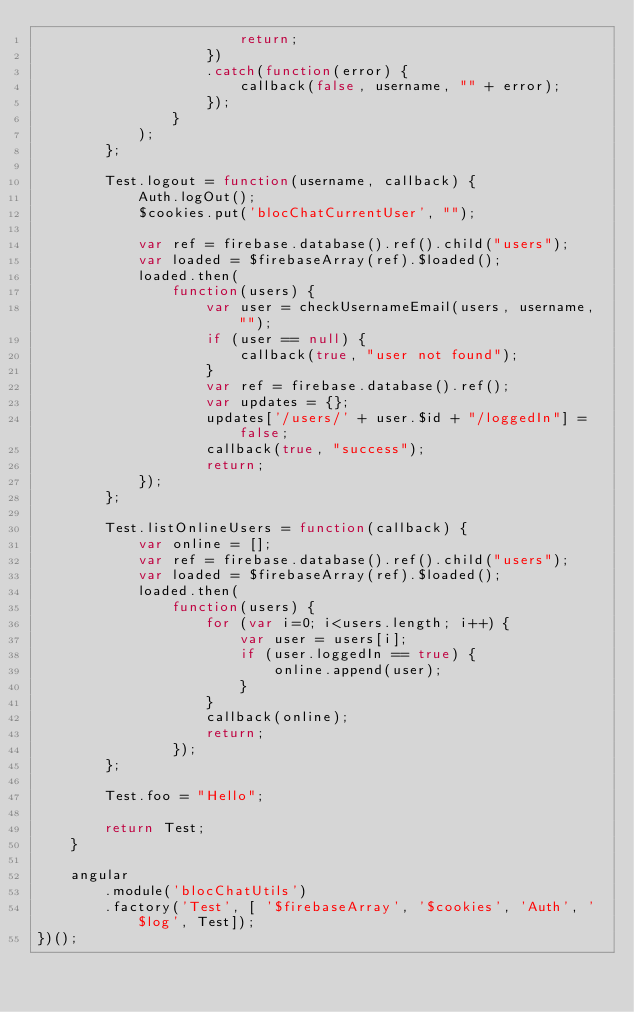<code> <loc_0><loc_0><loc_500><loc_500><_JavaScript_>                        return;
                    })
                    .catch(function(error) {
                        callback(false, username, "" + error);
                    });
                }
            );
        };
        
        Test.logout = function(username, callback) {
            Auth.logOut();
            $cookies.put('blocChatCurrentUser', "");
            
            var ref = firebase.database().ref().child("users");
            var loaded = $firebaseArray(ref).$loaded();
            loaded.then(
                function(users) {
                    var user = checkUsernameEmail(users, username, "");
                    if (user == null) {
                        callback(true, "user not found");
                    }
                    var ref = firebase.database().ref();
                    var updates = {};
                    updates['/users/' + user.$id + "/loggedIn"] = false;
                    callback(true, "success");
                    return;
            });
        };
        
        Test.listOnlineUsers = function(callback) {
            var online = [];
            var ref = firebase.database().ref().child("users");
            var loaded = $firebaseArray(ref).$loaded();
            loaded.then(
                function(users) {
                    for (var i=0; i<users.length; i++) {
                        var user = users[i];
                        if (user.loggedIn == true) {
                            online.append(user);
                        }
                    }
                    callback(online);
                    return;
                });
        };
        
        Test.foo = "Hello";
        
        return Test;
    }

    angular
        .module('blocChatUtils')
        .factory('Test', [ '$firebaseArray', '$cookies', 'Auth', '$log', Test]);
})();</code> 